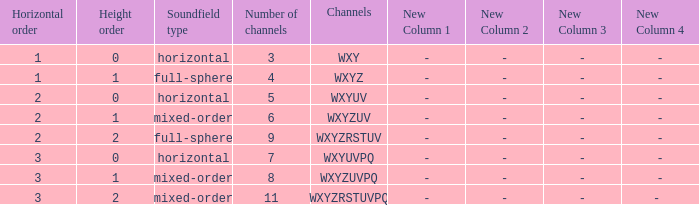If the channels is wxyzuv, what is the number of channels? 6.0. 